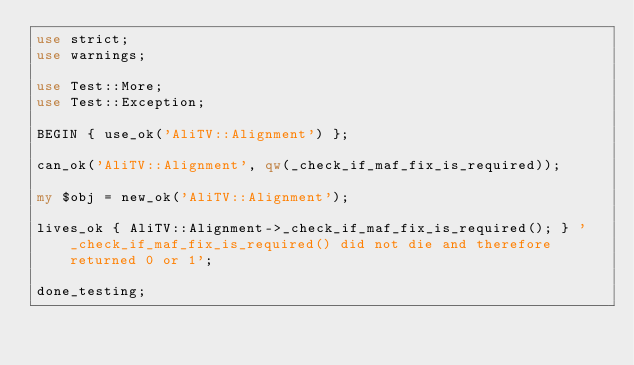Convert code to text. <code><loc_0><loc_0><loc_500><loc_500><_Perl_>use strict;
use warnings;

use Test::More;
use Test::Exception;

BEGIN { use_ok('AliTV::Alignment') };

can_ok('AliTV::Alignment', qw(_check_if_maf_fix_is_required));

my $obj = new_ok('AliTV::Alignment');

lives_ok { AliTV::Alignment->_check_if_maf_fix_is_required(); } '_check_if_maf_fix_is_required() did not die and therefore returned 0 or 1';

done_testing;
</code> 